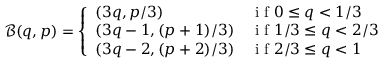Convert formula to latex. <formula><loc_0><loc_0><loc_500><loc_500>\mathcal { B } ( q , p ) = \left \{ \begin{array} { l l } { ( 3 q , p / 3 ) } & { i f 0 \leq q < 1 / 3 } \\ { ( 3 q - 1 , ( p + 1 ) / 3 ) } & { i f 1 / 3 \leq q < 2 / 3 } \\ { ( 3 q - 2 , ( p + 2 ) / 3 ) } & { i f 2 / 3 \leq q < 1 } \end{array}</formula> 